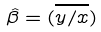<formula> <loc_0><loc_0><loc_500><loc_500>\hat { \beta } = ( \overline { y / x } )</formula> 